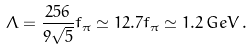Convert formula to latex. <formula><loc_0><loc_0><loc_500><loc_500>\Lambda = \frac { 2 5 6 } { 9 \sqrt { 5 } } f _ { \pi } \simeq 1 2 . 7 f _ { \pi } \simeq 1 . 2 \, G e V \, .</formula> 